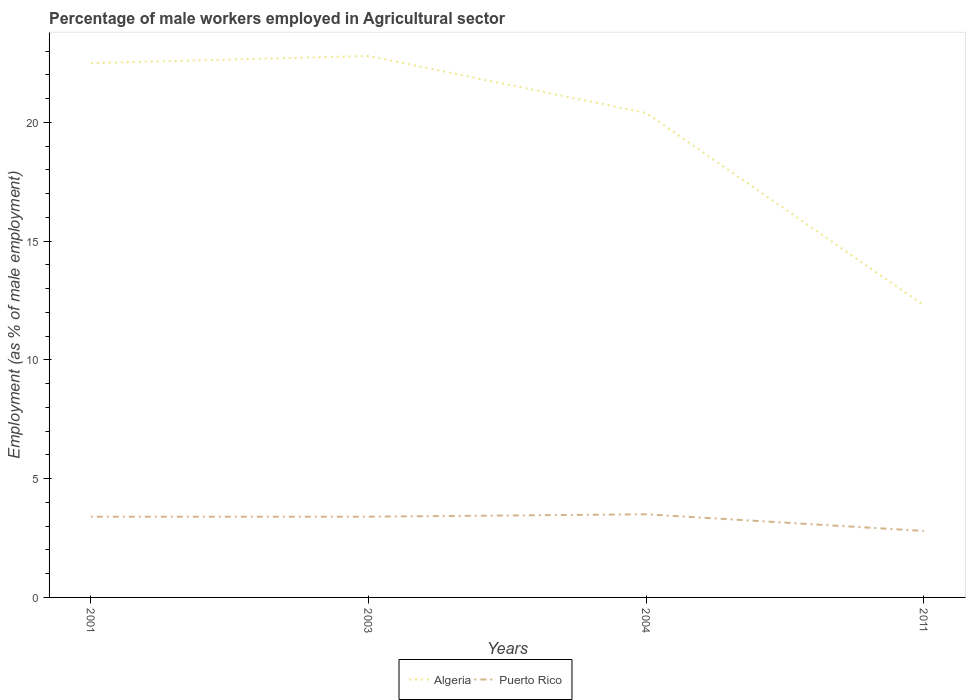How many different coloured lines are there?
Ensure brevity in your answer.  2. Is the number of lines equal to the number of legend labels?
Offer a terse response. Yes. Across all years, what is the maximum percentage of male workers employed in Agricultural sector in Algeria?
Provide a succinct answer. 12.3. What is the total percentage of male workers employed in Agricultural sector in Algeria in the graph?
Offer a terse response. 10.5. What is the difference between the highest and the second highest percentage of male workers employed in Agricultural sector in Algeria?
Give a very brief answer. 10.5. How many lines are there?
Your response must be concise. 2. How many years are there in the graph?
Offer a very short reply. 4. Are the values on the major ticks of Y-axis written in scientific E-notation?
Keep it short and to the point. No. How many legend labels are there?
Provide a succinct answer. 2. How are the legend labels stacked?
Provide a short and direct response. Horizontal. What is the title of the graph?
Give a very brief answer. Percentage of male workers employed in Agricultural sector. What is the label or title of the Y-axis?
Provide a short and direct response. Employment (as % of male employment). What is the Employment (as % of male employment) of Puerto Rico in 2001?
Your answer should be compact. 3.4. What is the Employment (as % of male employment) in Algeria in 2003?
Offer a very short reply. 22.8. What is the Employment (as % of male employment) in Puerto Rico in 2003?
Your response must be concise. 3.4. What is the Employment (as % of male employment) in Algeria in 2004?
Make the answer very short. 20.4. What is the Employment (as % of male employment) in Algeria in 2011?
Give a very brief answer. 12.3. What is the Employment (as % of male employment) in Puerto Rico in 2011?
Your answer should be very brief. 2.8. Across all years, what is the maximum Employment (as % of male employment) of Algeria?
Offer a terse response. 22.8. Across all years, what is the minimum Employment (as % of male employment) of Algeria?
Keep it short and to the point. 12.3. Across all years, what is the minimum Employment (as % of male employment) in Puerto Rico?
Give a very brief answer. 2.8. What is the total Employment (as % of male employment) in Algeria in the graph?
Your answer should be very brief. 78. What is the total Employment (as % of male employment) of Puerto Rico in the graph?
Your response must be concise. 13.1. What is the difference between the Employment (as % of male employment) of Algeria in 2001 and that in 2004?
Ensure brevity in your answer.  2.1. What is the difference between the Employment (as % of male employment) of Puerto Rico in 2001 and that in 2004?
Keep it short and to the point. -0.1. What is the difference between the Employment (as % of male employment) of Algeria in 2004 and that in 2011?
Keep it short and to the point. 8.1. What is the difference between the Employment (as % of male employment) of Puerto Rico in 2004 and that in 2011?
Your response must be concise. 0.7. What is the difference between the Employment (as % of male employment) in Algeria in 2001 and the Employment (as % of male employment) in Puerto Rico in 2003?
Keep it short and to the point. 19.1. What is the difference between the Employment (as % of male employment) in Algeria in 2003 and the Employment (as % of male employment) in Puerto Rico in 2004?
Ensure brevity in your answer.  19.3. What is the average Employment (as % of male employment) of Puerto Rico per year?
Your answer should be very brief. 3.27. In the year 2011, what is the difference between the Employment (as % of male employment) of Algeria and Employment (as % of male employment) of Puerto Rico?
Your answer should be compact. 9.5. What is the ratio of the Employment (as % of male employment) in Algeria in 2001 to that in 2003?
Provide a succinct answer. 0.99. What is the ratio of the Employment (as % of male employment) in Algeria in 2001 to that in 2004?
Ensure brevity in your answer.  1.1. What is the ratio of the Employment (as % of male employment) in Puerto Rico in 2001 to that in 2004?
Give a very brief answer. 0.97. What is the ratio of the Employment (as % of male employment) in Algeria in 2001 to that in 2011?
Your response must be concise. 1.83. What is the ratio of the Employment (as % of male employment) in Puerto Rico in 2001 to that in 2011?
Provide a short and direct response. 1.21. What is the ratio of the Employment (as % of male employment) in Algeria in 2003 to that in 2004?
Offer a very short reply. 1.12. What is the ratio of the Employment (as % of male employment) in Puerto Rico in 2003 to that in 2004?
Offer a very short reply. 0.97. What is the ratio of the Employment (as % of male employment) of Algeria in 2003 to that in 2011?
Your answer should be very brief. 1.85. What is the ratio of the Employment (as % of male employment) in Puerto Rico in 2003 to that in 2011?
Your answer should be very brief. 1.21. What is the ratio of the Employment (as % of male employment) in Algeria in 2004 to that in 2011?
Offer a terse response. 1.66. What is the difference between the highest and the second highest Employment (as % of male employment) of Puerto Rico?
Offer a very short reply. 0.1. What is the difference between the highest and the lowest Employment (as % of male employment) of Algeria?
Your response must be concise. 10.5. What is the difference between the highest and the lowest Employment (as % of male employment) in Puerto Rico?
Offer a terse response. 0.7. 